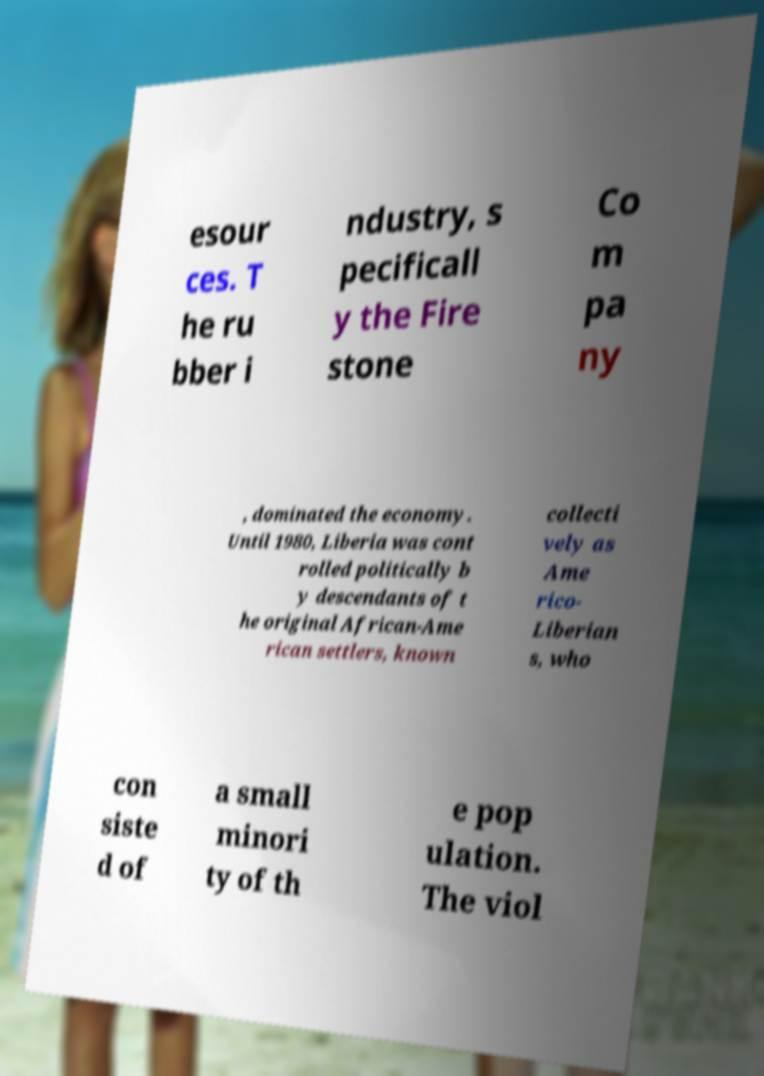Please read and relay the text visible in this image. What does it say? esour ces. T he ru bber i ndustry, s pecificall y the Fire stone Co m pa ny , dominated the economy. Until 1980, Liberia was cont rolled politically b y descendants of t he original African-Ame rican settlers, known collecti vely as Ame rico- Liberian s, who con siste d of a small minori ty of th e pop ulation. The viol 